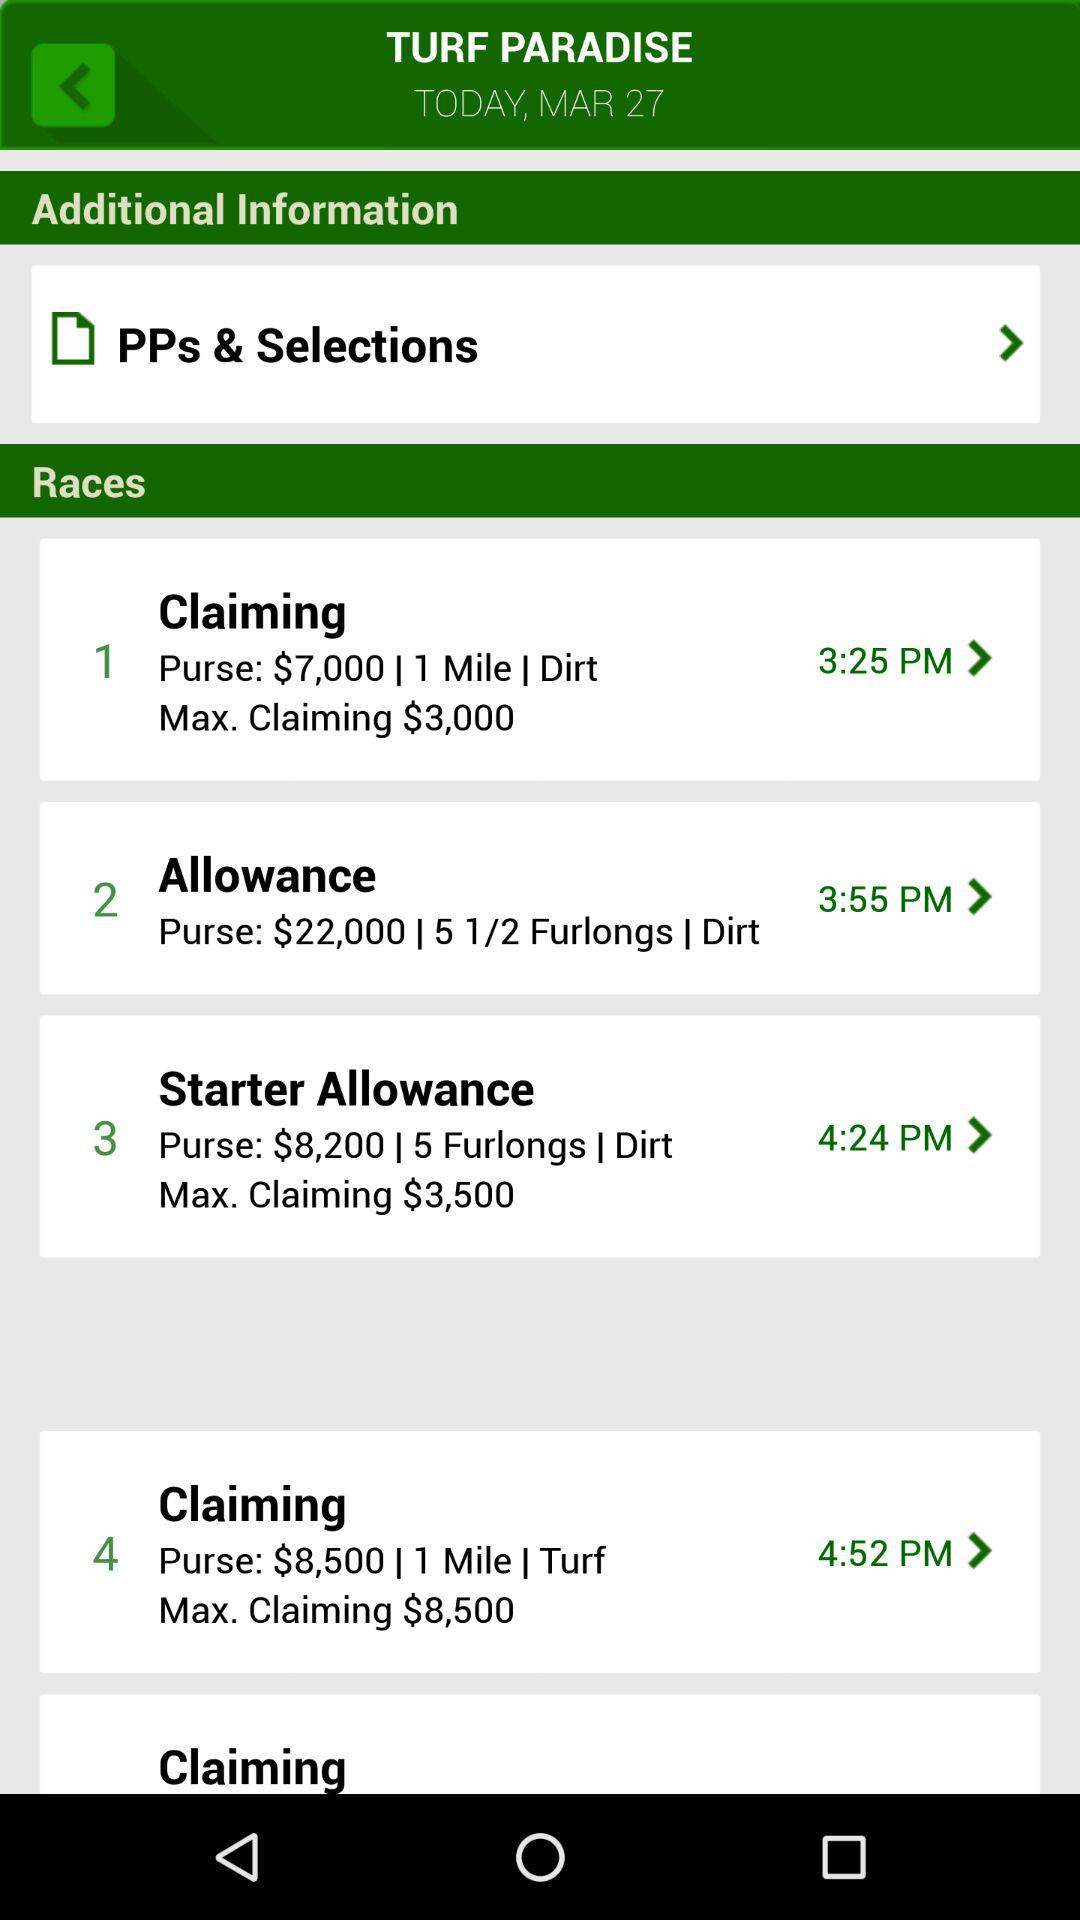How many races are scheduled for the day?
Answer the question using a single word or phrase. 4 